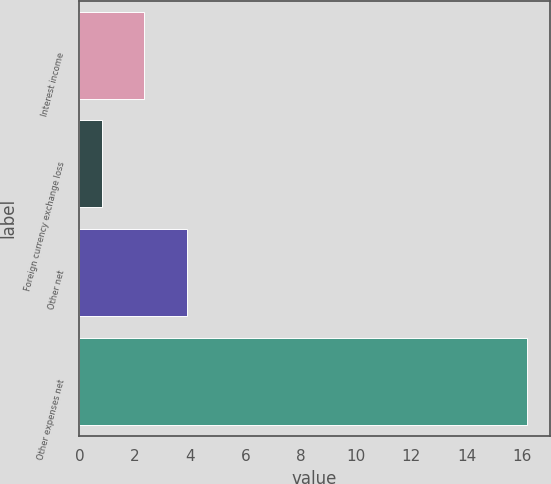<chart> <loc_0><loc_0><loc_500><loc_500><bar_chart><fcel>Interest income<fcel>Foreign currency exchange loss<fcel>Other net<fcel>Other expenses net<nl><fcel>2.34<fcel>0.8<fcel>3.88<fcel>16.2<nl></chart> 